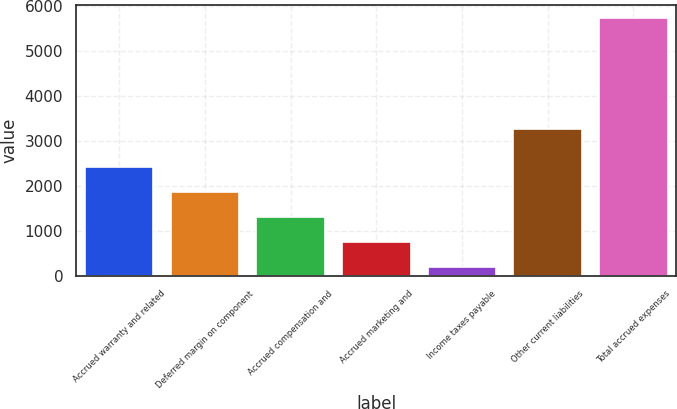Convert chart to OTSL. <chart><loc_0><loc_0><loc_500><loc_500><bar_chart><fcel>Accrued warranty and related<fcel>Deferred margin on component<fcel>Accrued compensation and<fcel>Accrued marketing and<fcel>Income taxes payable<fcel>Other current liabilities<fcel>Total accrued expenses<nl><fcel>2415.2<fcel>1863.9<fcel>1312.6<fcel>761.3<fcel>210<fcel>3257<fcel>5723<nl></chart> 